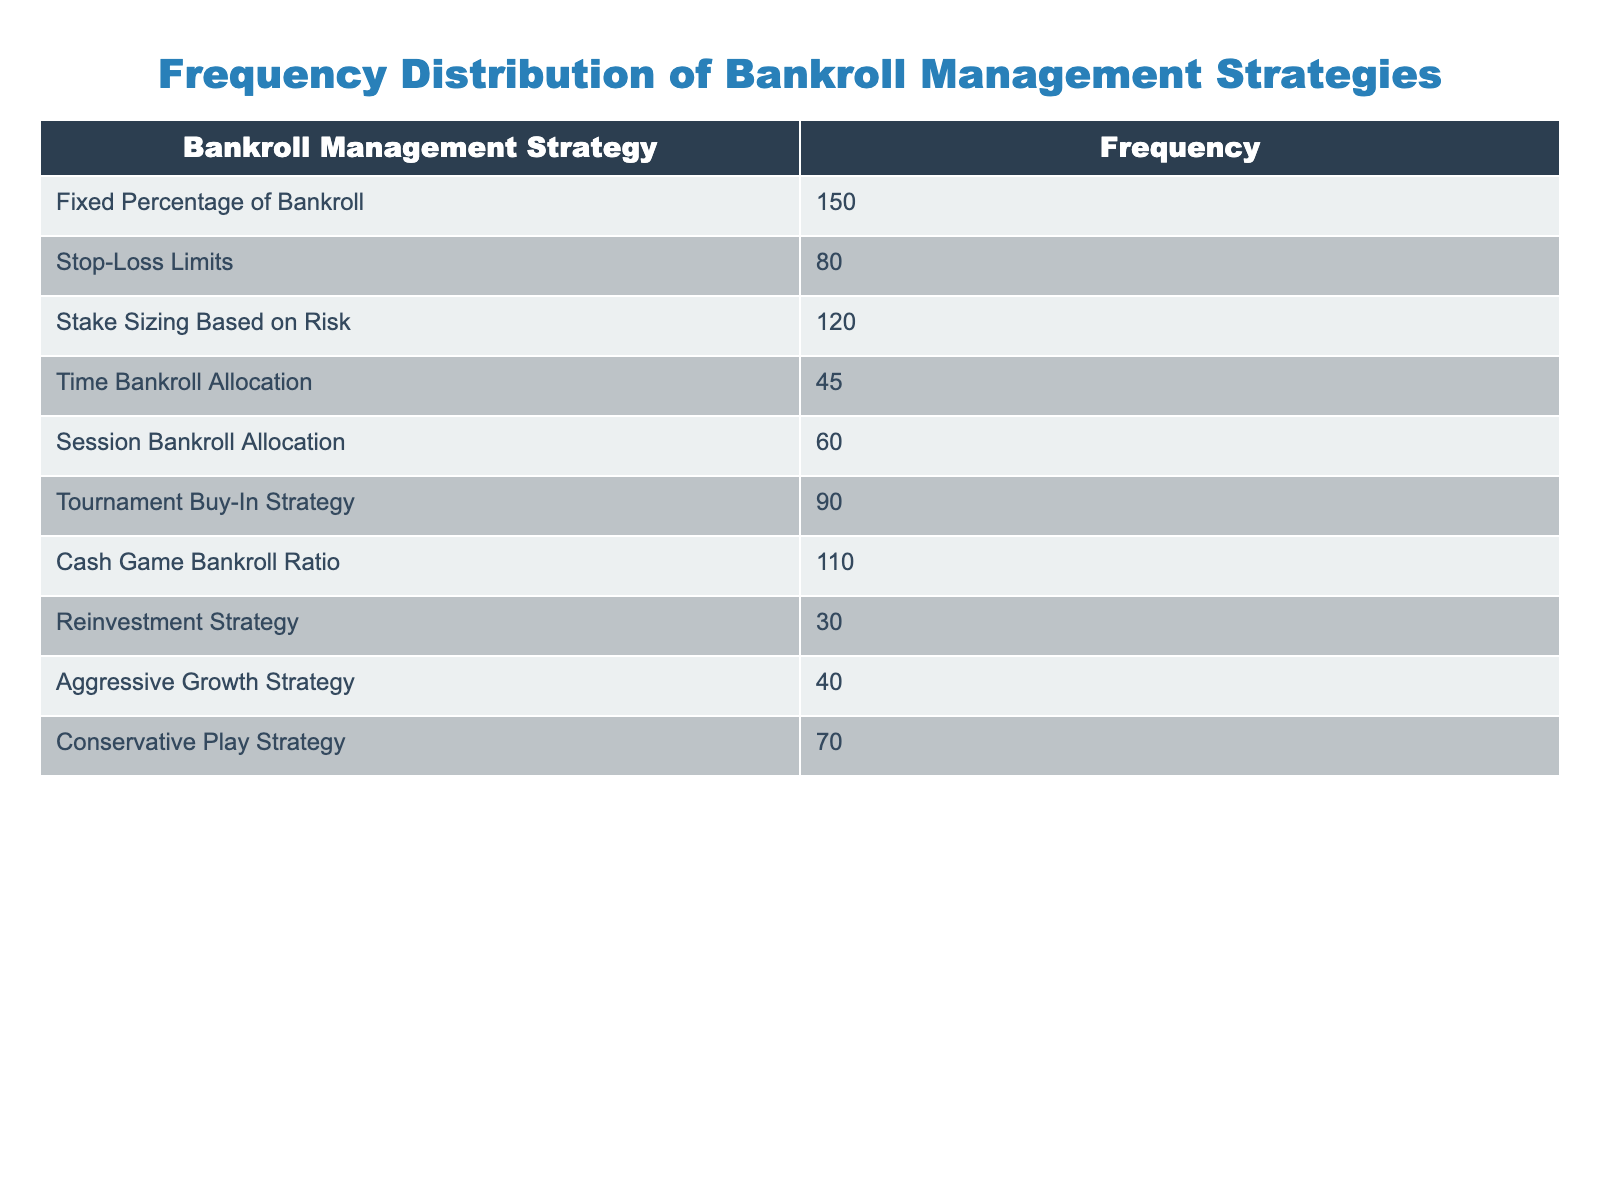What's the most frequently used bankroll management strategy? The table lists the frequency of different bankroll management strategies. By looking at the "Frequency" column, we can see that the strategy with the highest frequency is "Fixed Percentage of Bankroll," which has a frequency of 150.
Answer: Fixed Percentage of Bankroll What is the frequency of the "Reinvestment Strategy"? The table provides the frequency for each strategy, and the "Reinvestment Strategy" has a frequency of 30.
Answer: 30 What is the total frequency of strategies that have a frequency of 80 or more? We need to identify the strategies with frequencies of 80 or more: "Fixed Percentage of Bankroll" (150), "Stake Sizing Based on Risk" (120), "Cash Game Bankroll Ratio" (110), "Stop-Loss Limits" (80), and "Tournament Buy-In Strategy" (90). Adding these gives us a total of 150 + 120 + 110 + 80 + 90 = 650.
Answer: 650 Is the "Aggressive Growth Strategy" one of the top three most frequently used strategies? To determine this, we check the frequencies: The frequencies are 150, 120, 110, 90, 80, 70, 60, 45, 40, and 30. The top three strategies based on frequency are "Fixed Percentage of Bankroll," "Stake Sizing Based on Risk," and "Cash Game Bankroll Ratio." Since "Aggressive Growth Strategy" has a frequency of 40, it is not in the top three.
Answer: No What is the average frequency of all bankroll management strategies displayed? To find the average frequency, we first sum all the frequencies: 150 + 80 + 120 + 45 + 60 + 90 + 110 + 30 + 40 + 70 = 795. Since there are 10 strategies, we calculate the average as 795 / 10 = 79.5.
Answer: 79.5 Which strategy has the lowest frequency, and what is that frequency? By scanning the "Frequency" column, we find that "Reinvestment Strategy" has the lowest frequency at 30.
Answer: Reinvestment Strategy, 30 What is the difference in frequency between "Stop-Loss Limits" and "Session Bankroll Allocation"? "Stop-Loss Limits" has a frequency of 80, and "Session Bankroll Allocation" has a frequency of 60. The difference is calculated by subtracting the lower value from the higher value: 80 - 60 = 20.
Answer: 20 How many strategies have a frequency between 40 and 100? Looking at the frequencies, we have: "Stake Sizing Based on Risk" (120), "Stop-Loss Limits" (80), "Tournament Buy-In Strategy" (90), "Cash Game Bankroll Ratio" (110), "Conservative Play Strategy" (70), and "Session Bankroll Allocation" (60). The strategies within the range of 40 to 100 are "Stop-Loss Limits" (80), "Tournament Buy-In Strategy" (90), "Conservative Play Strategy" (70), and "Session Bankroll Allocation" (60). This totals to 4 strategies.
Answer: 4 What percentage of players use the "Fixed Percentage of Bankroll" strategy compared to the total players surveyed? The total surveyed is 795 (the sum of all frequencies), and the frequency for "Fixed Percentage of Bankroll" is 150. To find the percentage, we calculate: (150 / 795) * 100 = 18.87%.
Answer: Approximately 18.87% 